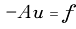Convert formula to latex. <formula><loc_0><loc_0><loc_500><loc_500>- { A } { u } = { f }</formula> 